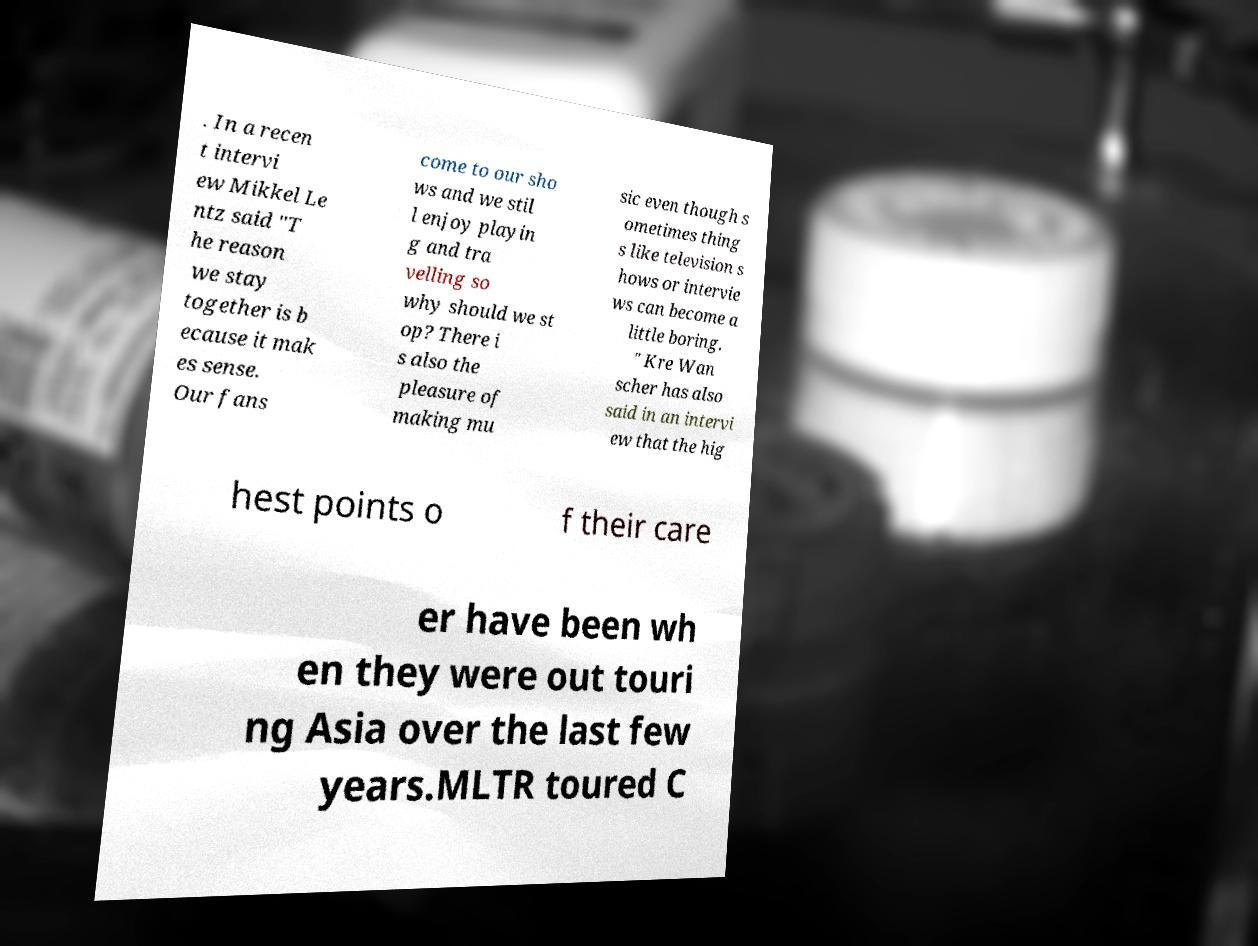Please identify and transcribe the text found in this image. . In a recen t intervi ew Mikkel Le ntz said "T he reason we stay together is b ecause it mak es sense. Our fans come to our sho ws and we stil l enjoy playin g and tra velling so why should we st op? There i s also the pleasure of making mu sic even though s ometimes thing s like television s hows or intervie ws can become a little boring. " Kre Wan scher has also said in an intervi ew that the hig hest points o f their care er have been wh en they were out touri ng Asia over the last few years.MLTR toured C 